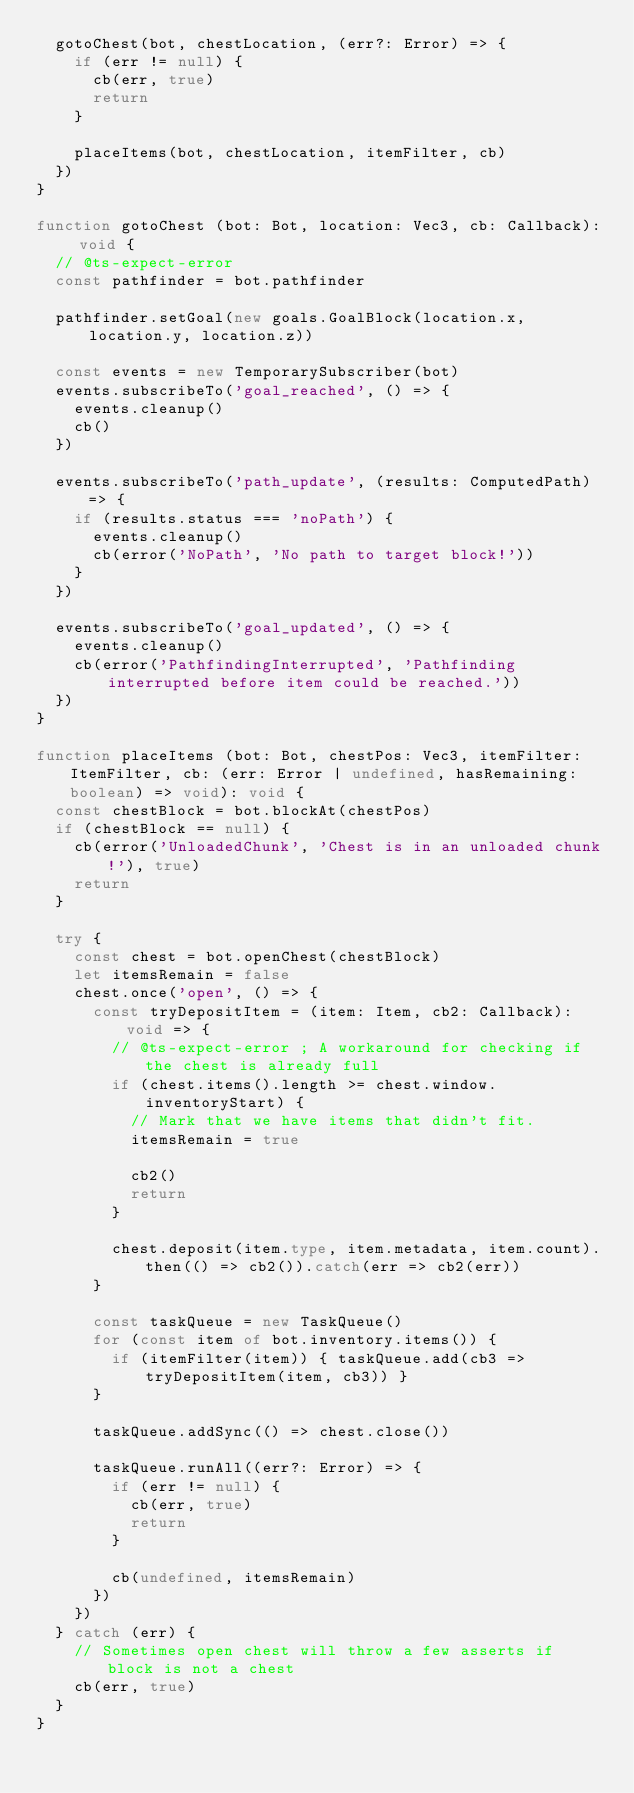<code> <loc_0><loc_0><loc_500><loc_500><_TypeScript_>  gotoChest(bot, chestLocation, (err?: Error) => {
    if (err != null) {
      cb(err, true)
      return
    }

    placeItems(bot, chestLocation, itemFilter, cb)
  })
}

function gotoChest (bot: Bot, location: Vec3, cb: Callback): void {
  // @ts-expect-error
  const pathfinder = bot.pathfinder

  pathfinder.setGoal(new goals.GoalBlock(location.x, location.y, location.z))

  const events = new TemporarySubscriber(bot)
  events.subscribeTo('goal_reached', () => {
    events.cleanup()
    cb()
  })

  events.subscribeTo('path_update', (results: ComputedPath) => {
    if (results.status === 'noPath') {
      events.cleanup()
      cb(error('NoPath', 'No path to target block!'))
    }
  })

  events.subscribeTo('goal_updated', () => {
    events.cleanup()
    cb(error('PathfindingInterrupted', 'Pathfinding interrupted before item could be reached.'))
  })
}

function placeItems (bot: Bot, chestPos: Vec3, itemFilter: ItemFilter, cb: (err: Error | undefined, hasRemaining: boolean) => void): void {
  const chestBlock = bot.blockAt(chestPos)
  if (chestBlock == null) {
    cb(error('UnloadedChunk', 'Chest is in an unloaded chunk!'), true)
    return
  }

  try {
    const chest = bot.openChest(chestBlock)
    let itemsRemain = false
    chest.once('open', () => {
      const tryDepositItem = (item: Item, cb2: Callback): void => {
        // @ts-expect-error ; A workaround for checking if the chest is already full
        if (chest.items().length >= chest.window.inventoryStart) {
          // Mark that we have items that didn't fit.
          itemsRemain = true

          cb2()
          return
        }

        chest.deposit(item.type, item.metadata, item.count).then(() => cb2()).catch(err => cb2(err))
      }

      const taskQueue = new TaskQueue()
      for (const item of bot.inventory.items()) {
        if (itemFilter(item)) { taskQueue.add(cb3 => tryDepositItem(item, cb3)) }
      }

      taskQueue.addSync(() => chest.close())

      taskQueue.runAll((err?: Error) => {
        if (err != null) {
          cb(err, true)
          return
        }

        cb(undefined, itemsRemain)
      })
    })
  } catch (err) {
    // Sometimes open chest will throw a few asserts if block is not a chest
    cb(err, true)
  }
}
</code> 